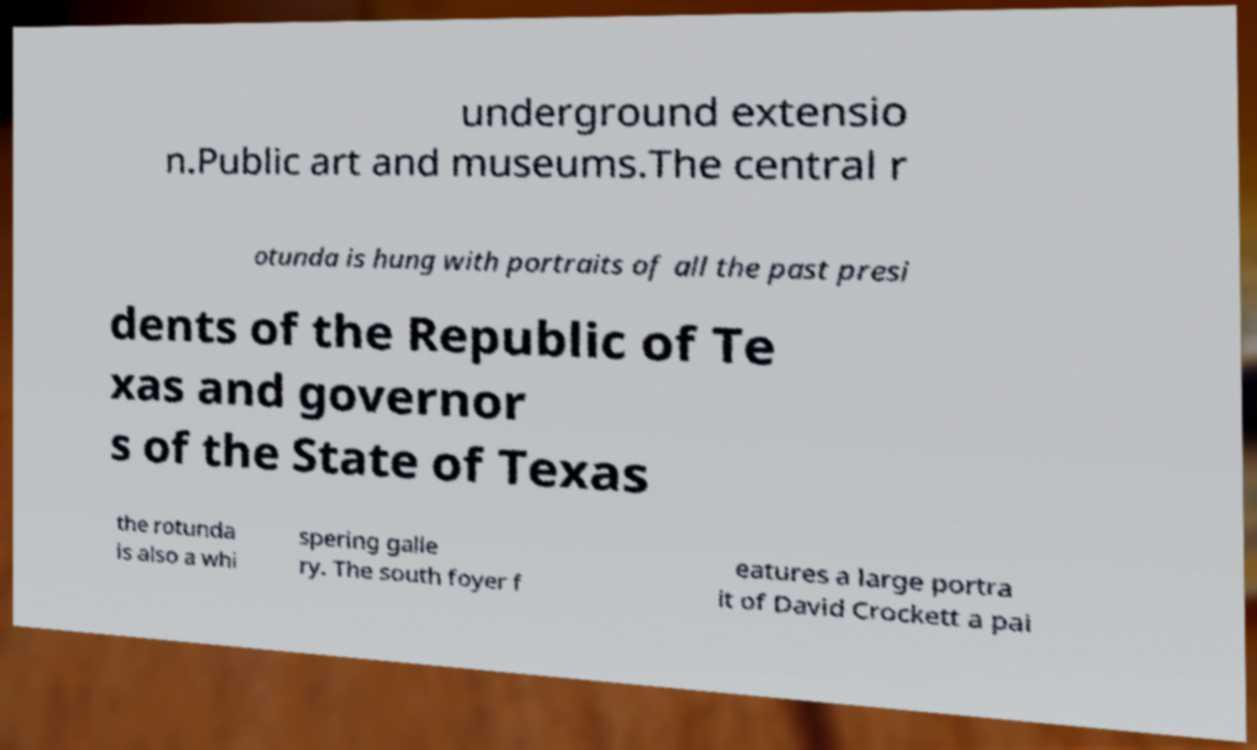Can you accurately transcribe the text from the provided image for me? underground extensio n.Public art and museums.The central r otunda is hung with portraits of all the past presi dents of the Republic of Te xas and governor s of the State of Texas the rotunda is also a whi spering galle ry. The south foyer f eatures a large portra it of David Crockett a pai 